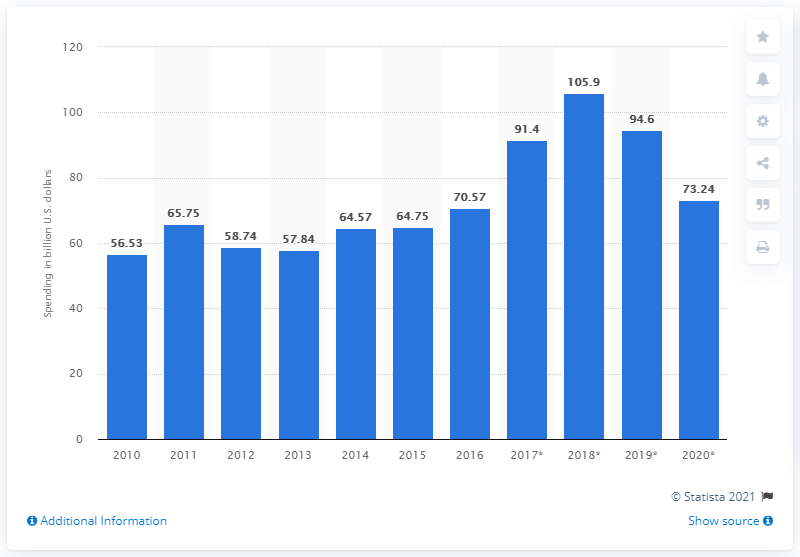Identify some key points in this picture. In 2016, global semiconductor capital spending was approximately 70.57. 